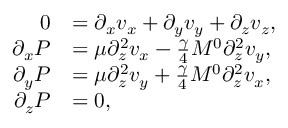<formula> <loc_0><loc_0><loc_500><loc_500>\begin{array} { r l } { 0 } & { = \partial _ { x } v _ { x } + \partial _ { y } v _ { y } + \partial _ { z } v _ { z } , } \\ { \partial _ { x } P } & { = \mu \partial _ { z } ^ { 2 } v _ { x } - \frac { \gamma } { 4 } M ^ { 0 } \partial _ { z } ^ { 2 } v _ { y } , } \\ { \partial _ { y } P } & { = \mu \partial _ { z } ^ { 2 } v _ { y } + \frac { \gamma } { 4 } M ^ { 0 } \partial _ { z } ^ { 2 } v _ { x } , } \\ { \partial _ { z } P } & { = 0 , } \end{array}</formula> 